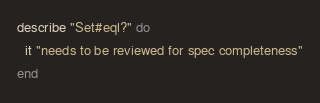Convert code to text. <code><loc_0><loc_0><loc_500><loc_500><_Ruby_>describe "Set#eql?" do
  it "needs to be reviewed for spec completeness"
end
</code> 